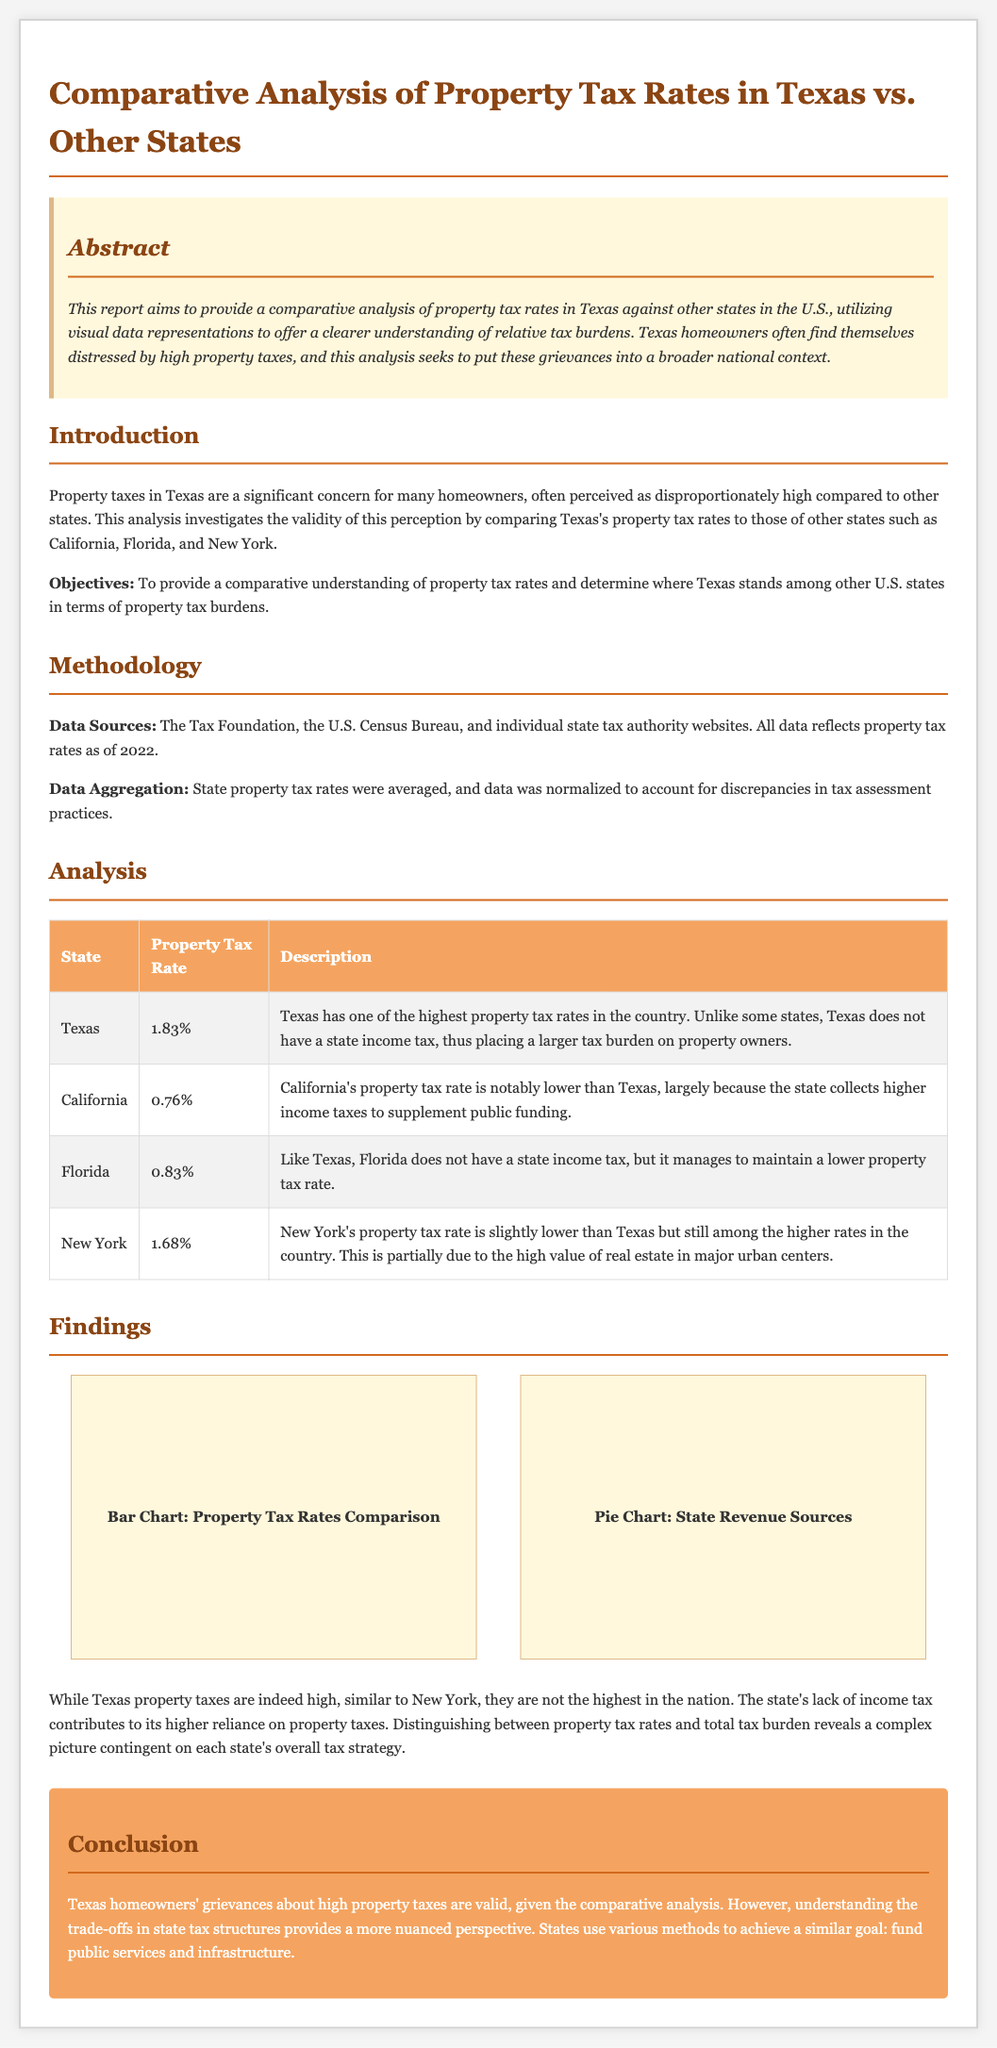What is the property tax rate in Texas? The document states that Texas has a property tax rate of 1.83%.
Answer: 1.83% Which state has the lowest property tax rate? According to the data in the document, California has the lowest property tax rate at 0.76%.
Answer: California What are the main data sources mentioned in the methodology? The document lists the Tax Foundation, the U.S. Census Bureau, and individual state tax authority websites as the main data sources.
Answer: Tax Foundation, U.S. Census Bureau, state tax authority websites How does Texas's property tax rate compare to New York's? The document notes that New York's property tax rate is slightly lower than Texas's, which indicates a direct comparison.
Answer: Slightly lower What conclusion is drawn regarding Texas homeowners' grievances? The report concludes that the grievances are valid, but there is a need for nuanced understanding of tax structures.
Answer: Valid grievances Which two states do not have a state income tax? The document mentions that both Texas and Florida do not have a state income tax while comparing the property tax rates.
Answer: Texas and Florida What is the purpose of the report? The document states that the purpose of the report is to provide a comparative analysis of property tax rates in Texas against other states.
Answer: Comparative analysis What type of charts are mentioned in the findings? The report refers to a bar chart for property tax rates comparison and a pie chart for state revenue sources.
Answer: Bar chart and pie chart 